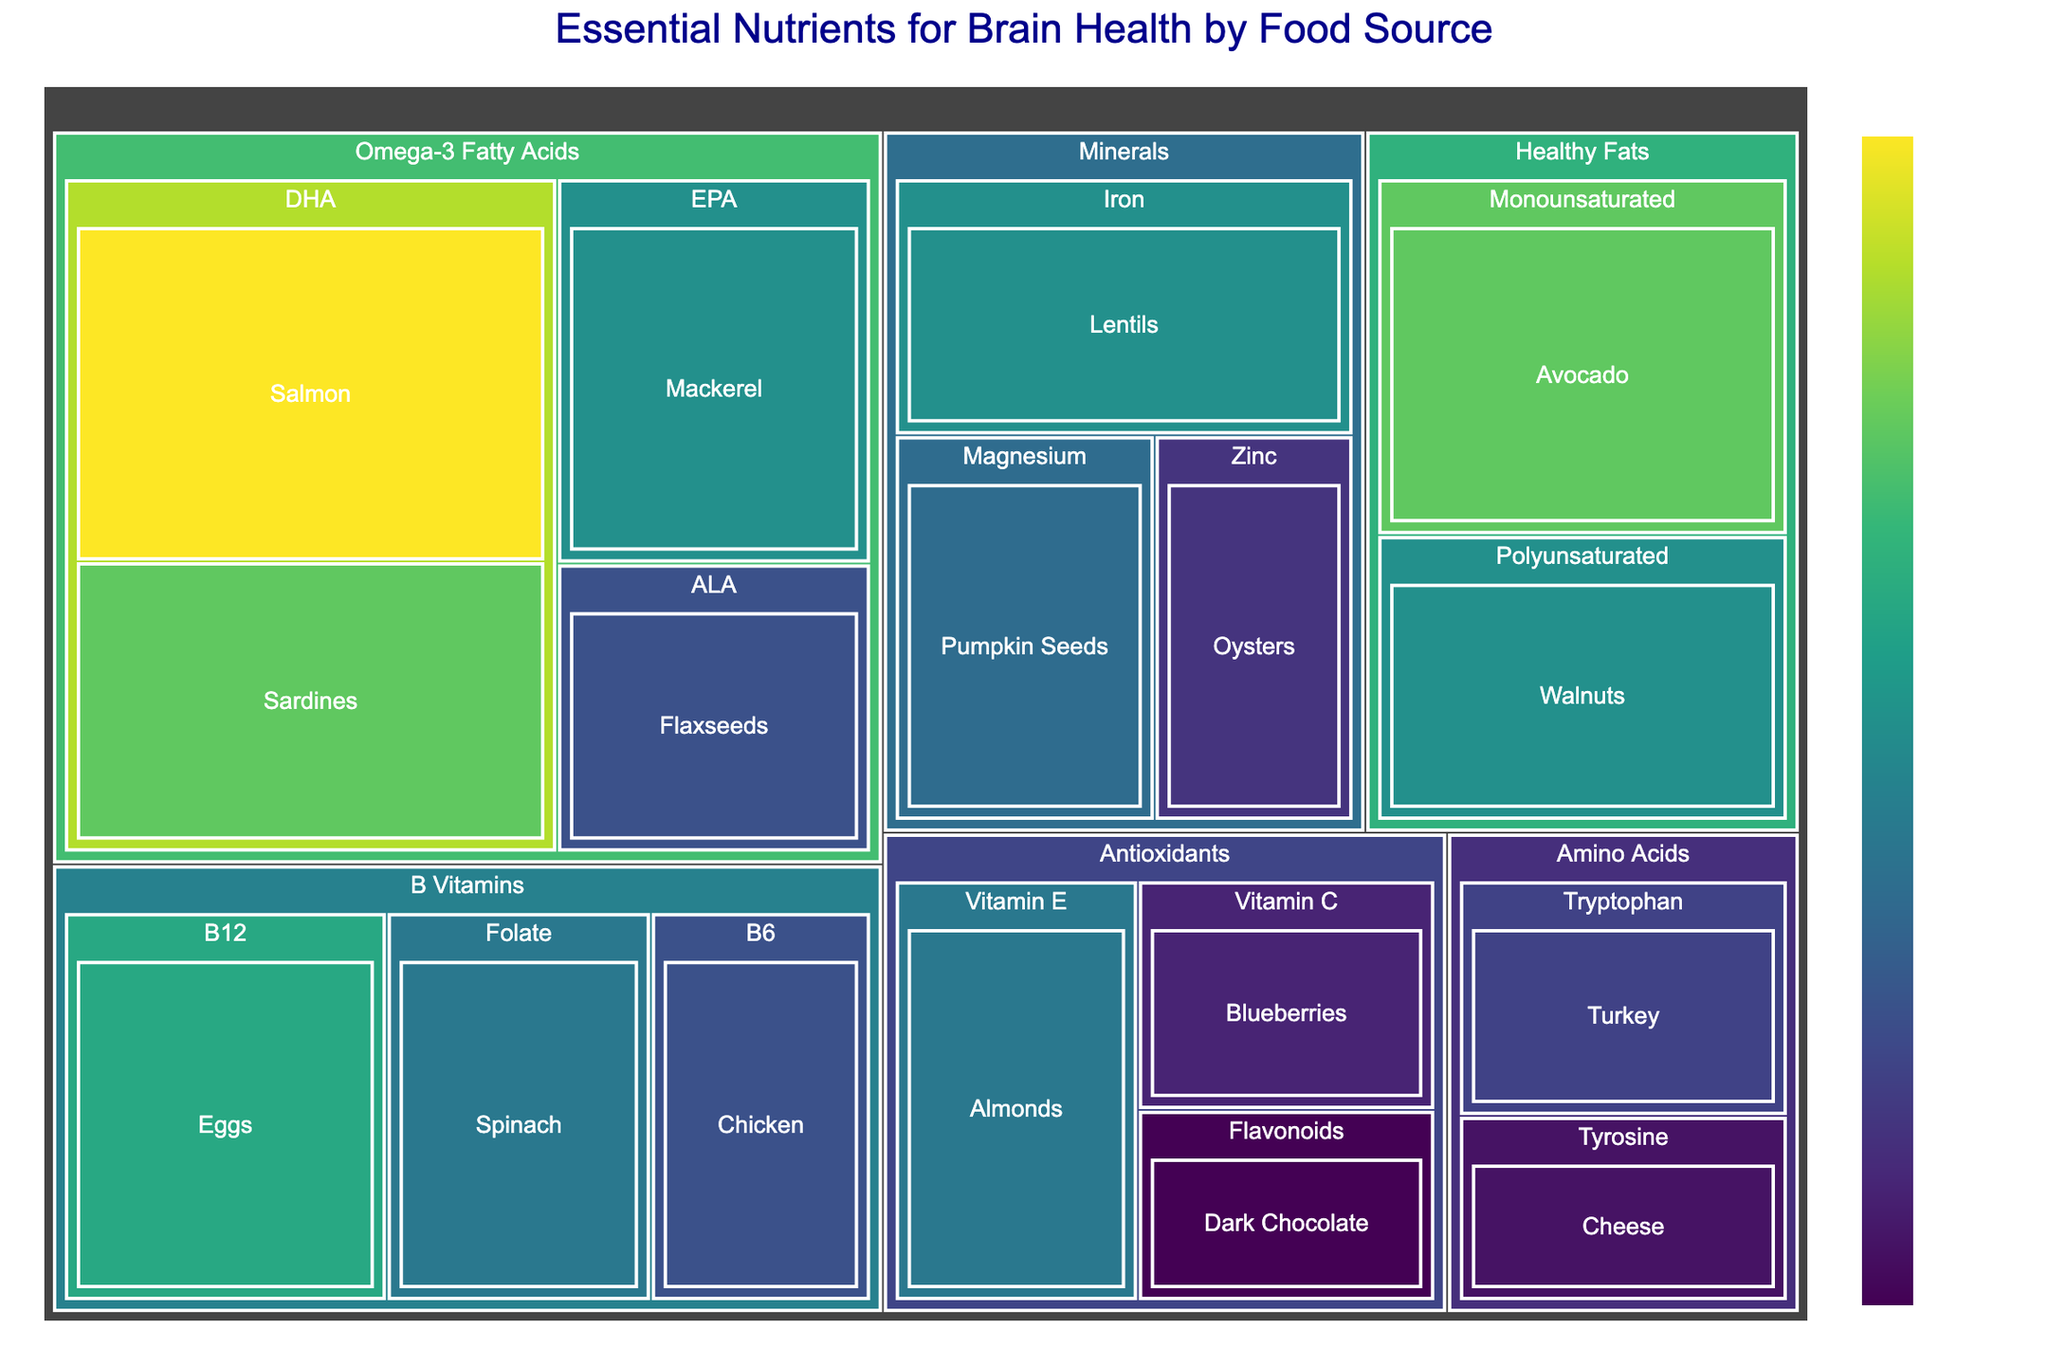What is the title of the treemap? The title of the treemap is usually positioned at the top of the figure and is written in a larger, distinct font compared to other texts. It provides a concise summary of the content and purpose of the chart.
Answer: Essential Nutrients for Brain Health by Food Source Which food source has the highest value for Omega-3 Fatty Acids? In the treemap, values for each food source are visually represented by the size of their respective sections and numerical labels. For Omega-3 Fatty Acids, we need to find the largest value within its section.
Answer: Salmon How many food sources are categorized under Minerals? The treemap categorizes data hierarchically. To find the number of food sources under Minerals, look for the section labeled "Minerals" and count the individual food sources within this section.
Answer: 3 What is the combined value of B Vitamins from Eggs and Spinach? Locate the values for B Vitamins under the individual food sources for Eggs and Spinach, then sum these values together. Eggs have a value of 22 and Spinach has 18, so the combined value is \( 22 + 18 = 40 \).
Answer: 40 Which category has the largest aggregate value? Sum the values of all food sources within each category to find the total for each one. Compare these totals to determine which is largest.
Answer: Omega-3 Fatty Acids Compare the values of Vitamin E and Vitamin C in Antioxidants. Which one is higher, and by how much? Locate the values for Vitamin E in Almonds and Vitamin C in Blueberries. Vitamin E has a value of 18, while Vitamin C has 12. Subtract the smaller value from the larger one to find the difference: \( 18 - 12 = 6 \).
Answer: Vitamin E, by 6 What is the average value for Healthy Fats? Identify the values for all food sources under the Healthy Fats category (25 for Monounsaturated and 20 for Polyunsaturated). Calculate the average by summing these values and dividing by the number of items: \( (25 + 20) / 2 = 22.5 \).
Answer: 22.5 Which food source under Amino Acids has the higher value, and what is the value? Examine the values for food sources under the Amino Acids category. Compare Turkey (Tryptophan) with a value of 14, and Cheese (Tyrosine) with a value of 11. Identify the higher value.
Answer: Turkey, 14 What is the sum of all values in the Antioxidants category? Sum the values of all food sources under the Antioxidants category: Almonds (Vitamin E) = 18, Blueberries (Vitamin C) = 12, Dark Chocolate (Flavonoids) = 10. The total is \( 18 + 12 + 10 = 40 \).
Answer: 40 How does the value for Lentils compare to that of Pumpkin Seeds in the Minerals category? Locate the values for Lentils (Iron) and Pumpkin Seeds (Magnesium) under the Minerals category. Lentils have a value of 20, and Pumpkin Seeds have 17. Determine which is higher and the difference: \( 20 - 17 = 3 \).
Answer: Lentils, by 3 